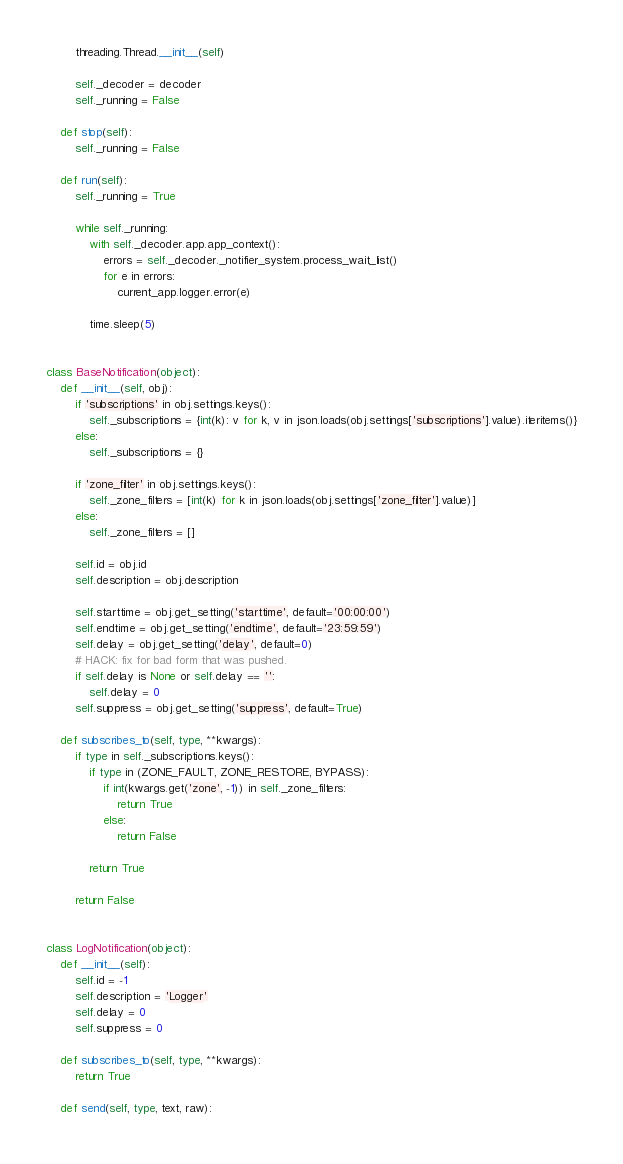<code> <loc_0><loc_0><loc_500><loc_500><_Python_>        threading.Thread.__init__(self)

        self._decoder = decoder
        self._running = False

    def stop(self):
        self._running = False

    def run(self):
        self._running = True

        while self._running:
            with self._decoder.app.app_context():
                errors = self._decoder._notifier_system.process_wait_list()
                for e in errors:
                    current_app.logger.error(e)

            time.sleep(5)


class BaseNotification(object):
    def __init__(self, obj):
        if 'subscriptions' in obj.settings.keys():
            self._subscriptions = {int(k): v for k, v in json.loads(obj.settings['subscriptions'].value).iteritems()}
        else:
            self._subscriptions = {}

        if 'zone_filter' in obj.settings.keys():
            self._zone_filters = [int(k) for k in json.loads(obj.settings['zone_filter'].value)]
        else:
            self._zone_filters = []

        self.id = obj.id
        self.description = obj.description

        self.starttime = obj.get_setting('starttime', default='00:00:00')
        self.endtime = obj.get_setting('endtime', default='23:59:59')
        self.delay = obj.get_setting('delay', default=0)
        # HACK: fix for bad form that was pushed.
        if self.delay is None or self.delay == '':
            self.delay = 0
        self.suppress = obj.get_setting('suppress', default=True)

    def subscribes_to(self, type, **kwargs):
        if type in self._subscriptions.keys():
            if type in (ZONE_FAULT, ZONE_RESTORE, BYPASS):
                if int(kwargs.get('zone', -1)) in self._zone_filters:
                    return True
                else:
                    return False

            return True

        return False


class LogNotification(object):
    def __init__(self):
        self.id = -1
        self.description = 'Logger'
        self.delay = 0
        self.suppress = 0

    def subscribes_to(self, type, **kwargs):
        return True

    def send(self, type, text, raw):</code> 